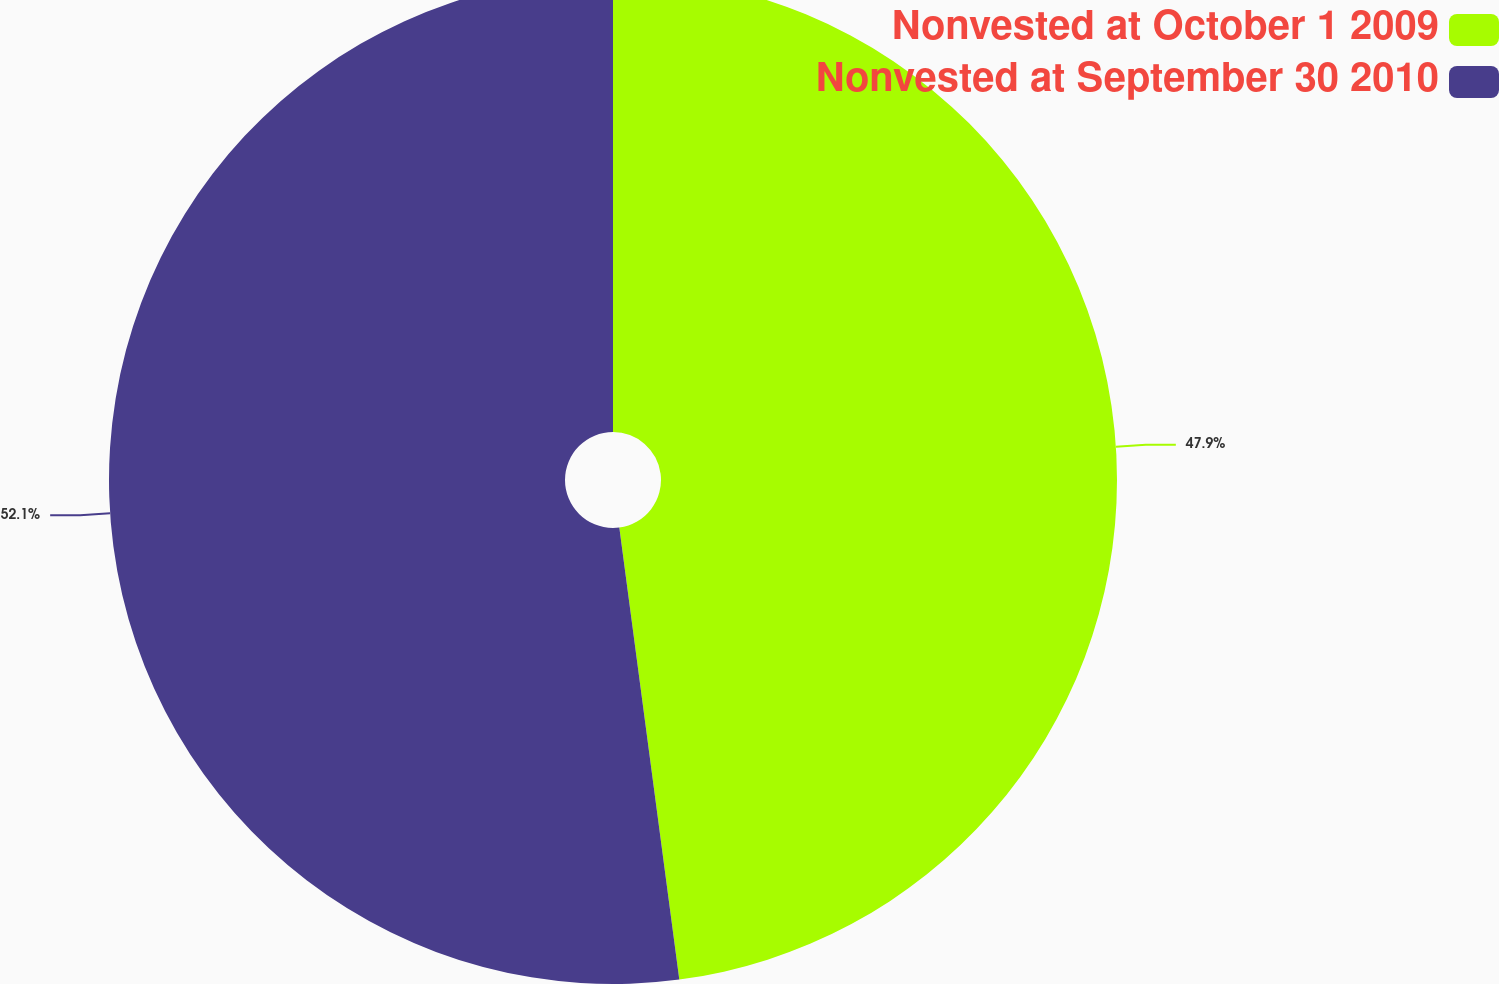<chart> <loc_0><loc_0><loc_500><loc_500><pie_chart><fcel>Nonvested at October 1 2009<fcel>Nonvested at September 30 2010<nl><fcel>47.9%<fcel>52.1%<nl></chart> 